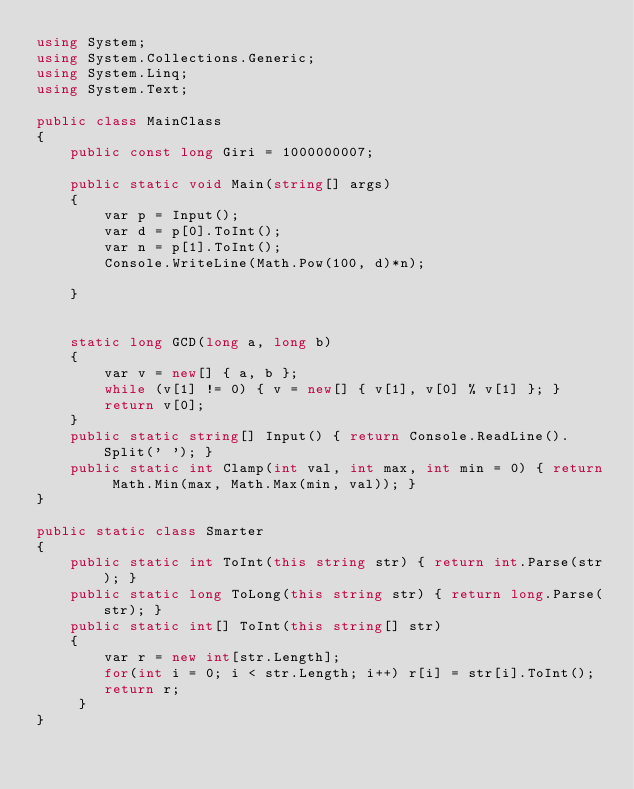<code> <loc_0><loc_0><loc_500><loc_500><_C#_>using System;
using System.Collections.Generic;
using System.Linq;
using System.Text;

public class MainClass
{
	public const long Giri = 1000000007;

	public static void Main(string[] args)
	{
		var p = Input();
		var d = p[0].ToInt();
		var n = p[1].ToInt();
		Console.WriteLine(Math.Pow(100, d)*n);
		
	}
	

	static long GCD(long a, long b)
	{
		var v = new[] { a, b };
		while (v[1] != 0) { v = new[] { v[1], v[0] % v[1] }; }
		return v[0];
	}
	public static string[] Input() { return Console.ReadLine().Split(' '); }
	public static int Clamp(int val, int max, int min = 0) { return Math.Min(max, Math.Max(min, val)); }
}

public static class Smarter
{
	public static int ToInt(this string str) { return int.Parse(str); }
	public static long ToLong(this string str) { return long.Parse(str); }
	public static int[] ToInt(this string[] str)
	{
		var r = new int[str.Length];
		for(int i = 0; i < str.Length; i++) r[i] = str[i].ToInt();
		return r;
	 }
}

</code> 